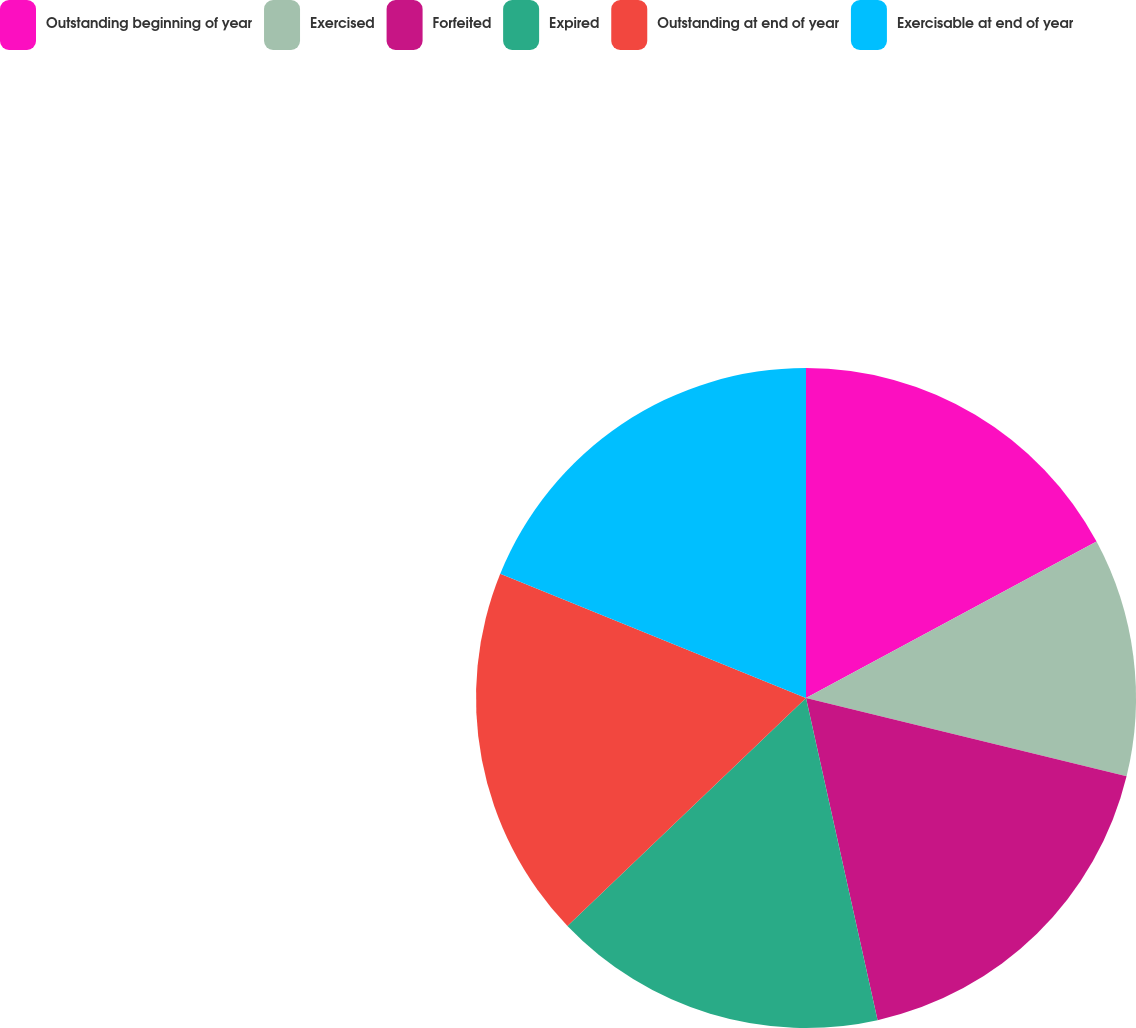Convert chart. <chart><loc_0><loc_0><loc_500><loc_500><pie_chart><fcel>Outstanding beginning of year<fcel>Exercised<fcel>Forfeited<fcel>Expired<fcel>Outstanding at end of year<fcel>Exercisable at end of year<nl><fcel>17.14%<fcel>11.67%<fcel>17.71%<fcel>16.34%<fcel>18.28%<fcel>18.86%<nl></chart> 